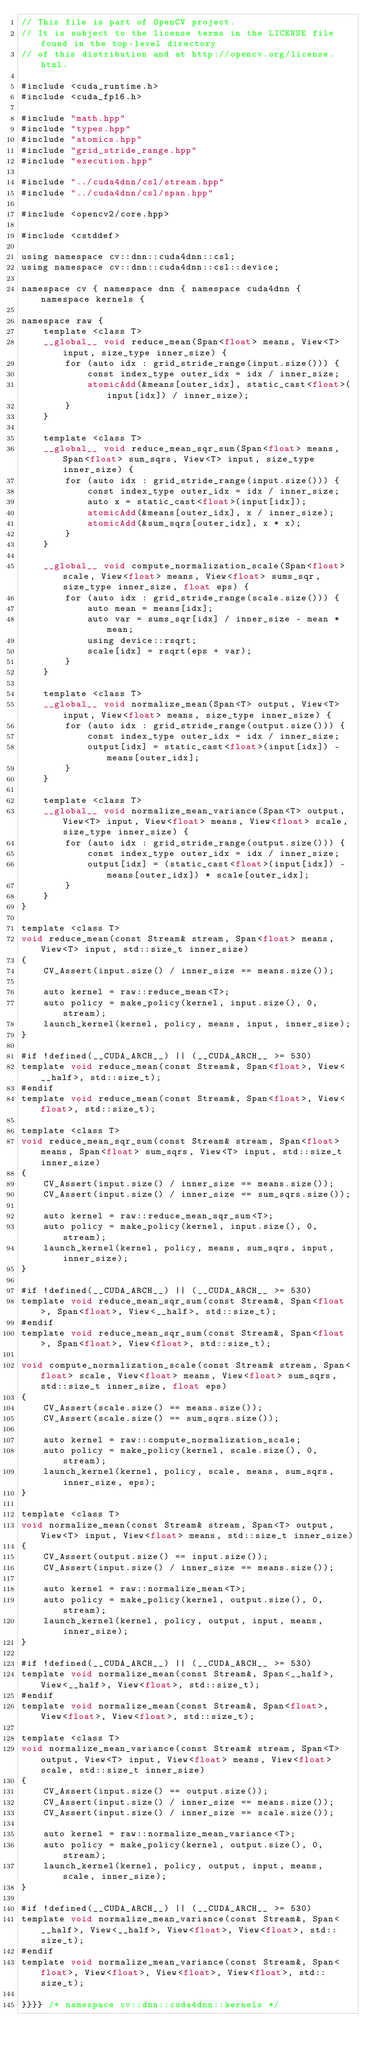Convert code to text. <code><loc_0><loc_0><loc_500><loc_500><_Cuda_>// This file is part of OpenCV project.
// It is subject to the license terms in the LICENSE file found in the top-level directory
// of this distribution and at http://opencv.org/license.html.

#include <cuda_runtime.h>
#include <cuda_fp16.h>

#include "math.hpp"
#include "types.hpp"
#include "atomics.hpp"
#include "grid_stride_range.hpp"
#include "execution.hpp"

#include "../cuda4dnn/csl/stream.hpp"
#include "../cuda4dnn/csl/span.hpp"

#include <opencv2/core.hpp>

#include <cstddef>

using namespace cv::dnn::cuda4dnn::csl;
using namespace cv::dnn::cuda4dnn::csl::device;

namespace cv { namespace dnn { namespace cuda4dnn { namespace kernels {

namespace raw {
    template <class T>
    __global__ void reduce_mean(Span<float> means, View<T> input, size_type inner_size) {
        for (auto idx : grid_stride_range(input.size())) {
            const index_type outer_idx = idx / inner_size;
            atomicAdd(&means[outer_idx], static_cast<float>(input[idx]) / inner_size);
        }
    }

    template <class T>
    __global__ void reduce_mean_sqr_sum(Span<float> means, Span<float> sum_sqrs, View<T> input, size_type inner_size) {
        for (auto idx : grid_stride_range(input.size())) {
            const index_type outer_idx = idx / inner_size;
            auto x = static_cast<float>(input[idx]);
            atomicAdd(&means[outer_idx], x / inner_size);
            atomicAdd(&sum_sqrs[outer_idx], x * x);
        }
    }

    __global__ void compute_normalization_scale(Span<float> scale, View<float> means, View<float> sums_sqr, size_type inner_size, float eps) {
        for (auto idx : grid_stride_range(scale.size())) {
            auto mean = means[idx];
            auto var = sums_sqr[idx] / inner_size - mean * mean;
            using device::rsqrt;
            scale[idx] = rsqrt(eps + var);
        }
    }

    template <class T>
    __global__ void normalize_mean(Span<T> output, View<T> input, View<float> means, size_type inner_size) {
        for (auto idx : grid_stride_range(output.size())) {
            const index_type outer_idx = idx / inner_size;
            output[idx] = static_cast<float>(input[idx]) - means[outer_idx];
        }
    }

    template <class T>
    __global__ void normalize_mean_variance(Span<T> output, View<T> input, View<float> means, View<float> scale, size_type inner_size) {
        for (auto idx : grid_stride_range(output.size())) {
            const index_type outer_idx = idx / inner_size;
            output[idx] = (static_cast<float>(input[idx]) - means[outer_idx]) * scale[outer_idx];
        }
    }
}

template <class T>
void reduce_mean(const Stream& stream, Span<float> means, View<T> input, std::size_t inner_size)
{
    CV_Assert(input.size() / inner_size == means.size());

    auto kernel = raw::reduce_mean<T>;
    auto policy = make_policy(kernel, input.size(), 0, stream);
    launch_kernel(kernel, policy, means, input, inner_size);
}

#if !defined(__CUDA_ARCH__) || (__CUDA_ARCH__ >= 530)
template void reduce_mean(const Stream&, Span<float>, View<__half>, std::size_t);
#endif
template void reduce_mean(const Stream&, Span<float>, View<float>, std::size_t);

template <class T>
void reduce_mean_sqr_sum(const Stream& stream, Span<float> means, Span<float> sum_sqrs, View<T> input, std::size_t inner_size)
{
    CV_Assert(input.size() / inner_size == means.size());
    CV_Assert(input.size() / inner_size == sum_sqrs.size());

    auto kernel = raw::reduce_mean_sqr_sum<T>;
    auto policy = make_policy(kernel, input.size(), 0, stream);
    launch_kernel(kernel, policy, means, sum_sqrs, input, inner_size);
}

#if !defined(__CUDA_ARCH__) || (__CUDA_ARCH__ >= 530)
template void reduce_mean_sqr_sum(const Stream&, Span<float>, Span<float>, View<__half>, std::size_t);
#endif
template void reduce_mean_sqr_sum(const Stream&, Span<float>, Span<float>, View<float>, std::size_t);

void compute_normalization_scale(const Stream& stream, Span<float> scale, View<float> means, View<float> sum_sqrs, std::size_t inner_size, float eps)
{
    CV_Assert(scale.size() == means.size());
    CV_Assert(scale.size() == sum_sqrs.size());

    auto kernel = raw::compute_normalization_scale;
    auto policy = make_policy(kernel, scale.size(), 0, stream);
    launch_kernel(kernel, policy, scale, means, sum_sqrs, inner_size, eps);
}

template <class T>
void normalize_mean(const Stream& stream, Span<T> output, View<T> input, View<float> means, std::size_t inner_size)
{
    CV_Assert(output.size() == input.size());
    CV_Assert(input.size() / inner_size == means.size());

    auto kernel = raw::normalize_mean<T>;
    auto policy = make_policy(kernel, output.size(), 0, stream);
    launch_kernel(kernel, policy, output, input, means, inner_size);
}

#if !defined(__CUDA_ARCH__) || (__CUDA_ARCH__ >= 530)
template void normalize_mean(const Stream&, Span<__half>, View<__half>, View<float>, std::size_t);
#endif
template void normalize_mean(const Stream&, Span<float>, View<float>, View<float>, std::size_t);

template <class T>
void normalize_mean_variance(const Stream& stream, Span<T> output, View<T> input, View<float> means, View<float> scale, std::size_t inner_size)
{
    CV_Assert(input.size() == output.size());
    CV_Assert(input.size() / inner_size == means.size());
    CV_Assert(input.size() / inner_size == scale.size());

    auto kernel = raw::normalize_mean_variance<T>;
    auto policy = make_policy(kernel, output.size(), 0, stream);
    launch_kernel(kernel, policy, output, input, means, scale, inner_size);
}

#if !defined(__CUDA_ARCH__) || (__CUDA_ARCH__ >= 530)
template void normalize_mean_variance(const Stream&, Span<__half>, View<__half>, View<float>, View<float>, std::size_t);
#endif
template void normalize_mean_variance(const Stream&, Span<float>, View<float>, View<float>, View<float>, std::size_t);

}}}} /* namespace cv::dnn::cuda4dnn::kernels */
</code> 